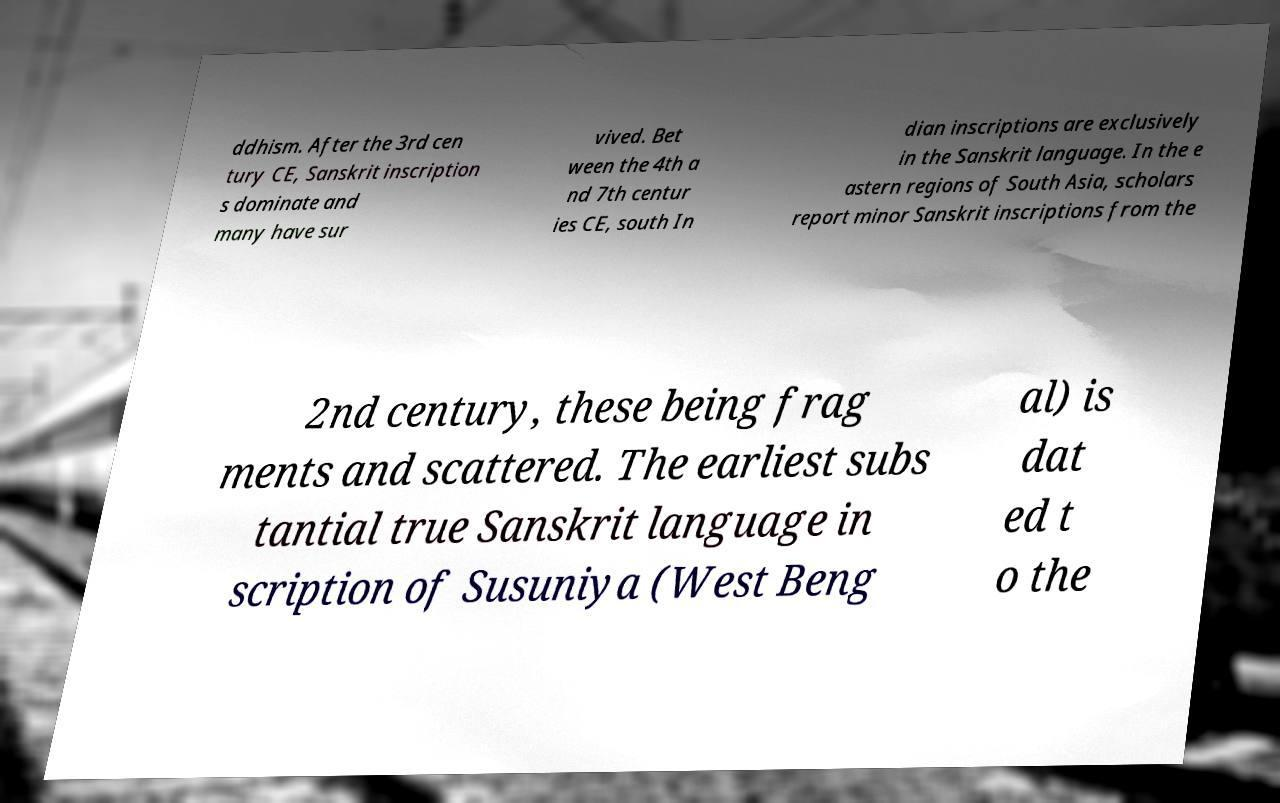For documentation purposes, I need the text within this image transcribed. Could you provide that? ddhism. After the 3rd cen tury CE, Sanskrit inscription s dominate and many have sur vived. Bet ween the 4th a nd 7th centur ies CE, south In dian inscriptions are exclusively in the Sanskrit language. In the e astern regions of South Asia, scholars report minor Sanskrit inscriptions from the 2nd century, these being frag ments and scattered. The earliest subs tantial true Sanskrit language in scription of Susuniya (West Beng al) is dat ed t o the 